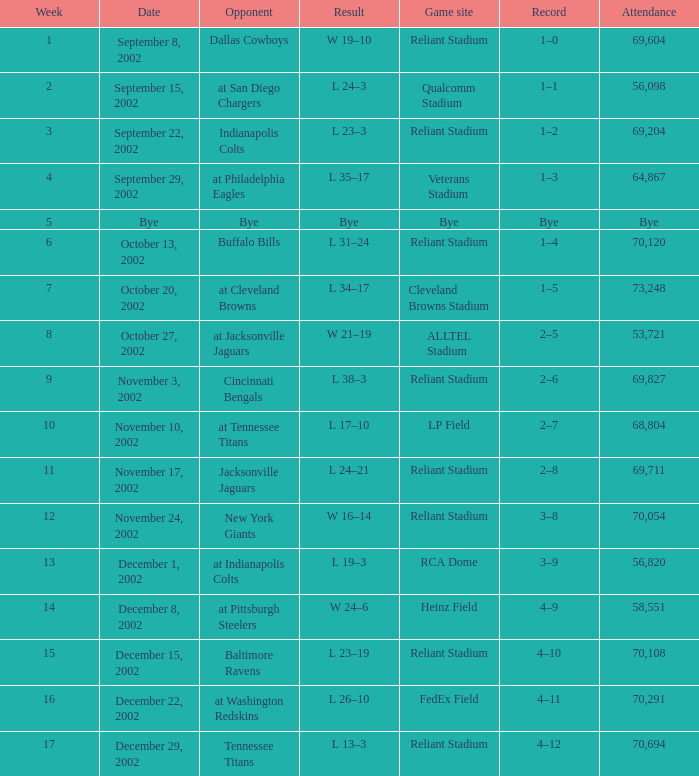During which week did the texans initially play at the cleveland browns stadium? 7.0. 